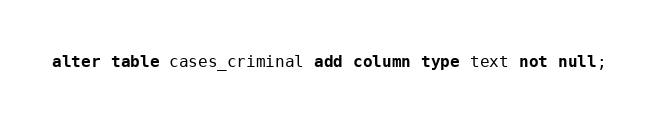Convert code to text. <code><loc_0><loc_0><loc_500><loc_500><_SQL_>alter table cases_criminal add column type text not null;
</code> 